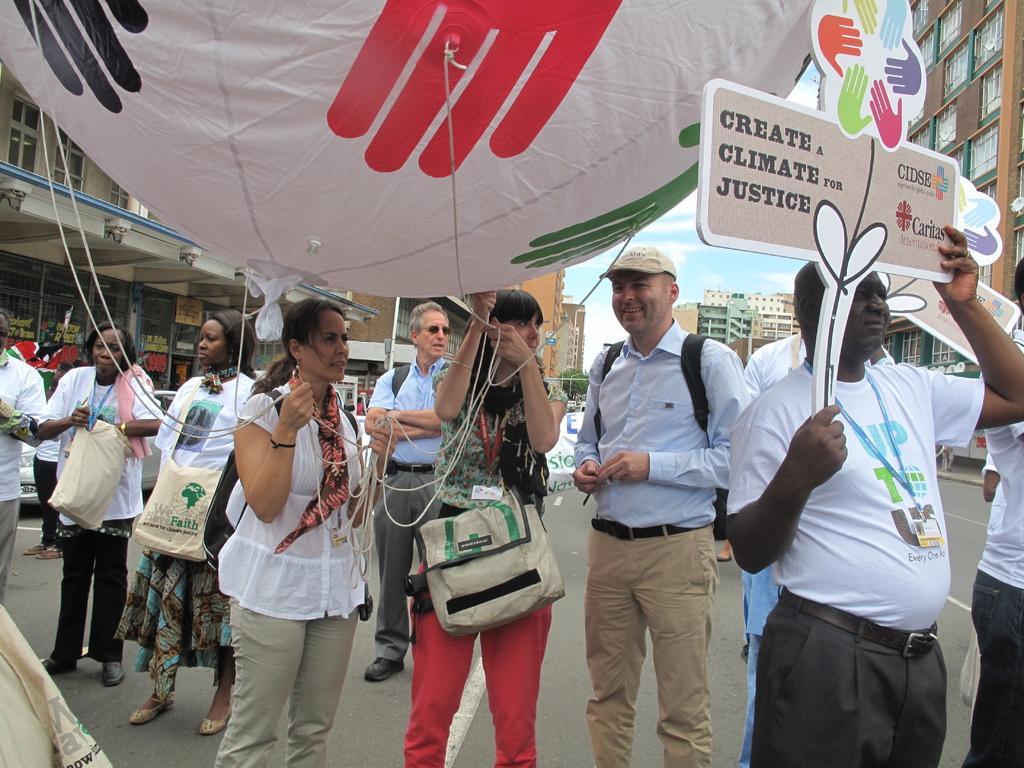Could you give a brief overview of what you see in this image? In this image we can see a group of people standing on the road. In that we can see some people holding a balloon with the ropes. On the right side we can see a person holding a board. On the backside we can see some buildings with windows and the sky which looks cloudy. 